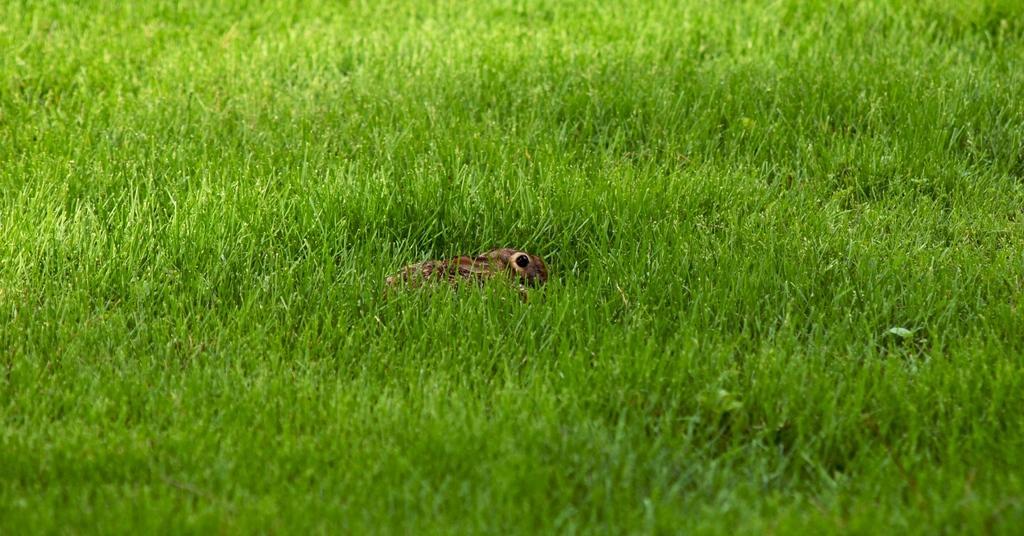Can you describe this image briefly? In this image we can see grass and in the grass it looks like an animal. 